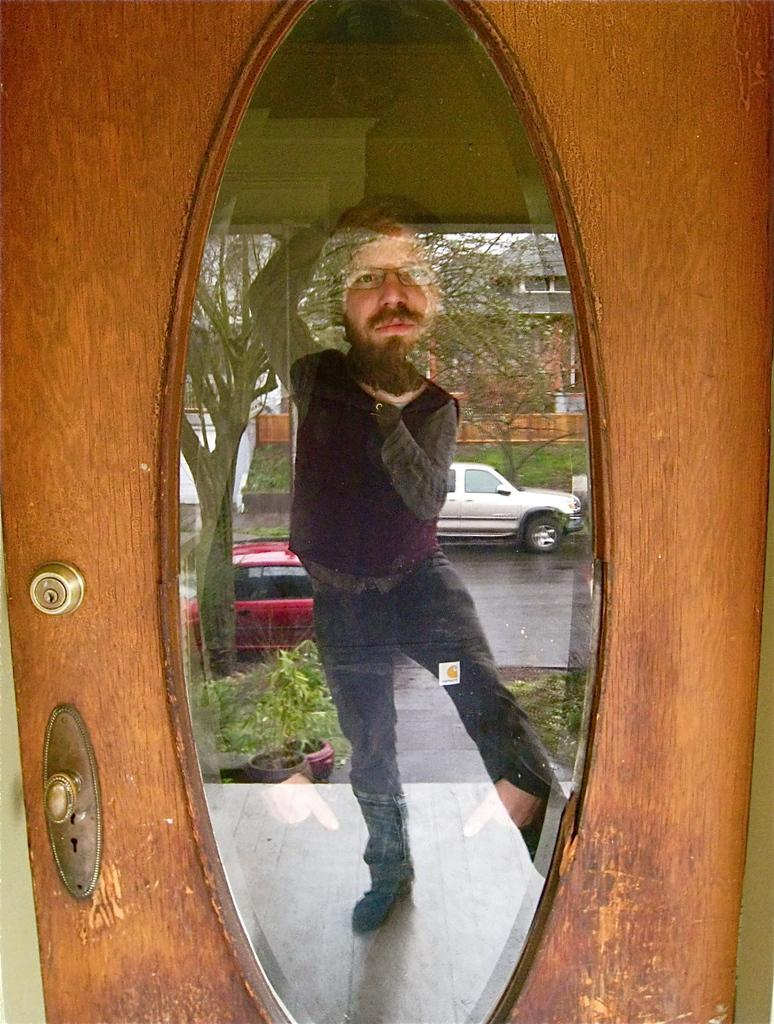What is reflected in the image? There is a reflection of a mirror in the image. What can be seen in the reflection? A person, a vehicle, and trees are visible in the reflection. Where is the writer sitting in the image? There is no writer present in the image; it only shows a reflection of a mirror with a person, a vehicle, and trees. 